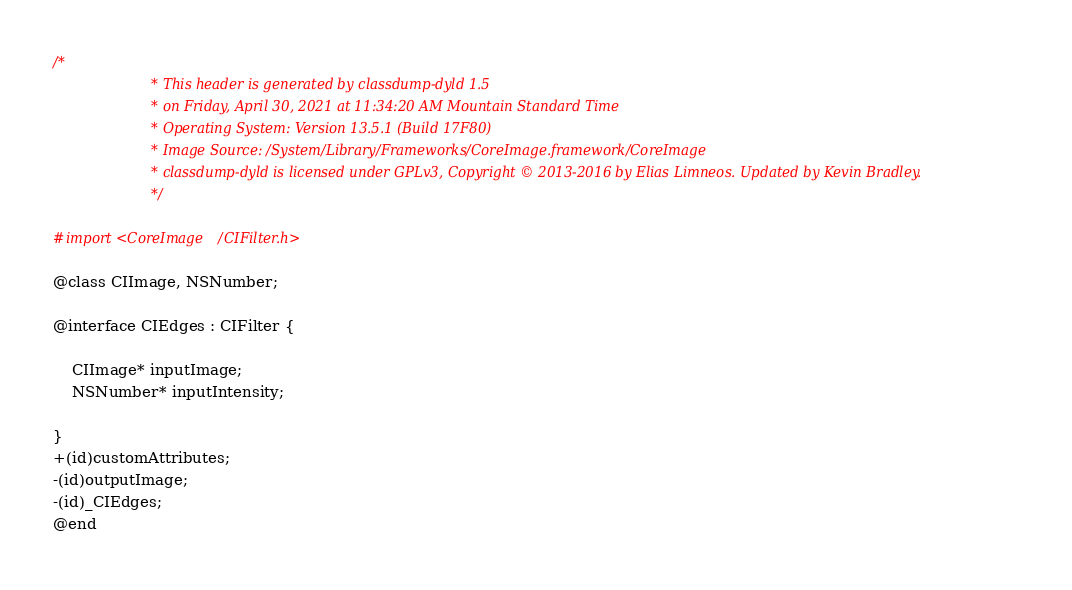Convert code to text. <code><loc_0><loc_0><loc_500><loc_500><_C_>/*
                       * This header is generated by classdump-dyld 1.5
                       * on Friday, April 30, 2021 at 11:34:20 AM Mountain Standard Time
                       * Operating System: Version 13.5.1 (Build 17F80)
                       * Image Source: /System/Library/Frameworks/CoreImage.framework/CoreImage
                       * classdump-dyld is licensed under GPLv3, Copyright © 2013-2016 by Elias Limneos. Updated by Kevin Bradley.
                       */

#import <CoreImage/CIFilter.h>

@class CIImage, NSNumber;

@interface CIEdges : CIFilter {

	CIImage* inputImage;
	NSNumber* inputIntensity;

}
+(id)customAttributes;
-(id)outputImage;
-(id)_CIEdges;
@end

</code> 